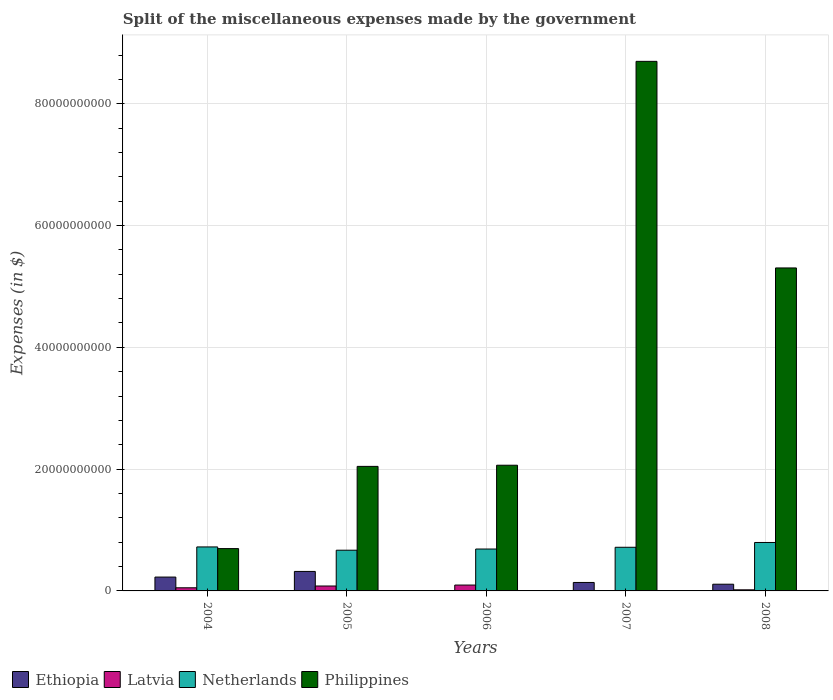How many different coloured bars are there?
Keep it short and to the point. 4. How many groups of bars are there?
Ensure brevity in your answer.  5. Are the number of bars per tick equal to the number of legend labels?
Provide a short and direct response. Yes. Are the number of bars on each tick of the X-axis equal?
Provide a succinct answer. Yes. How many bars are there on the 2nd tick from the left?
Your answer should be compact. 4. How many bars are there on the 5th tick from the right?
Give a very brief answer. 4. What is the miscellaneous expenses made by the government in Philippines in 2007?
Your answer should be compact. 8.70e+1. Across all years, what is the maximum miscellaneous expenses made by the government in Philippines?
Your response must be concise. 8.70e+1. Across all years, what is the minimum miscellaneous expenses made by the government in Ethiopia?
Provide a short and direct response. 6.20e+06. In which year was the miscellaneous expenses made by the government in Ethiopia maximum?
Provide a succinct answer. 2005. What is the total miscellaneous expenses made by the government in Netherlands in the graph?
Your response must be concise. 3.59e+1. What is the difference between the miscellaneous expenses made by the government in Ethiopia in 2006 and that in 2008?
Give a very brief answer. -1.09e+09. What is the difference between the miscellaneous expenses made by the government in Latvia in 2005 and the miscellaneous expenses made by the government in Ethiopia in 2006?
Ensure brevity in your answer.  8.00e+08. What is the average miscellaneous expenses made by the government in Netherlands per year?
Keep it short and to the point. 7.18e+09. In the year 2008, what is the difference between the miscellaneous expenses made by the government in Philippines and miscellaneous expenses made by the government in Netherlands?
Ensure brevity in your answer.  4.51e+1. What is the ratio of the miscellaneous expenses made by the government in Ethiopia in 2005 to that in 2007?
Keep it short and to the point. 2.3. Is the miscellaneous expenses made by the government in Philippines in 2004 less than that in 2006?
Provide a short and direct response. Yes. Is the difference between the miscellaneous expenses made by the government in Philippines in 2006 and 2007 greater than the difference between the miscellaneous expenses made by the government in Netherlands in 2006 and 2007?
Make the answer very short. No. What is the difference between the highest and the second highest miscellaneous expenses made by the government in Philippines?
Your response must be concise. 3.39e+1. What is the difference between the highest and the lowest miscellaneous expenses made by the government in Latvia?
Ensure brevity in your answer.  9.51e+08. What does the 2nd bar from the left in 2005 represents?
Give a very brief answer. Latvia. What does the 4th bar from the right in 2005 represents?
Provide a short and direct response. Ethiopia. Is it the case that in every year, the sum of the miscellaneous expenses made by the government in Philippines and miscellaneous expenses made by the government in Ethiopia is greater than the miscellaneous expenses made by the government in Latvia?
Provide a short and direct response. Yes. What is the difference between two consecutive major ticks on the Y-axis?
Offer a terse response. 2.00e+1. Are the values on the major ticks of Y-axis written in scientific E-notation?
Your answer should be very brief. No. Where does the legend appear in the graph?
Give a very brief answer. Bottom left. How many legend labels are there?
Make the answer very short. 4. What is the title of the graph?
Keep it short and to the point. Split of the miscellaneous expenses made by the government. What is the label or title of the X-axis?
Give a very brief answer. Years. What is the label or title of the Y-axis?
Your response must be concise. Expenses (in $). What is the Expenses (in $) in Ethiopia in 2004?
Offer a terse response. 2.27e+09. What is the Expenses (in $) of Latvia in 2004?
Provide a short and direct response. 5.13e+08. What is the Expenses (in $) of Netherlands in 2004?
Your answer should be compact. 7.22e+09. What is the Expenses (in $) of Philippines in 2004?
Offer a very short reply. 6.95e+09. What is the Expenses (in $) of Ethiopia in 2005?
Your answer should be very brief. 3.20e+09. What is the Expenses (in $) in Latvia in 2005?
Your answer should be very brief. 8.06e+08. What is the Expenses (in $) of Netherlands in 2005?
Ensure brevity in your answer.  6.69e+09. What is the Expenses (in $) in Philippines in 2005?
Your answer should be compact. 2.04e+1. What is the Expenses (in $) in Ethiopia in 2006?
Provide a succinct answer. 6.20e+06. What is the Expenses (in $) in Latvia in 2006?
Keep it short and to the point. 9.62e+08. What is the Expenses (in $) of Netherlands in 2006?
Offer a very short reply. 6.88e+09. What is the Expenses (in $) of Philippines in 2006?
Your answer should be compact. 2.06e+1. What is the Expenses (in $) in Ethiopia in 2007?
Keep it short and to the point. 1.39e+09. What is the Expenses (in $) of Latvia in 2007?
Provide a succinct answer. 1.14e+07. What is the Expenses (in $) of Netherlands in 2007?
Provide a short and direct response. 7.17e+09. What is the Expenses (in $) in Philippines in 2007?
Your response must be concise. 8.70e+1. What is the Expenses (in $) in Ethiopia in 2008?
Give a very brief answer. 1.10e+09. What is the Expenses (in $) in Latvia in 2008?
Your answer should be very brief. 1.80e+08. What is the Expenses (in $) in Netherlands in 2008?
Keep it short and to the point. 7.96e+09. What is the Expenses (in $) in Philippines in 2008?
Provide a short and direct response. 5.30e+1. Across all years, what is the maximum Expenses (in $) in Ethiopia?
Your answer should be very brief. 3.20e+09. Across all years, what is the maximum Expenses (in $) in Latvia?
Ensure brevity in your answer.  9.62e+08. Across all years, what is the maximum Expenses (in $) in Netherlands?
Keep it short and to the point. 7.96e+09. Across all years, what is the maximum Expenses (in $) in Philippines?
Provide a short and direct response. 8.70e+1. Across all years, what is the minimum Expenses (in $) of Ethiopia?
Your answer should be compact. 6.20e+06. Across all years, what is the minimum Expenses (in $) in Latvia?
Ensure brevity in your answer.  1.14e+07. Across all years, what is the minimum Expenses (in $) in Netherlands?
Offer a very short reply. 6.69e+09. Across all years, what is the minimum Expenses (in $) of Philippines?
Ensure brevity in your answer.  6.95e+09. What is the total Expenses (in $) of Ethiopia in the graph?
Your response must be concise. 7.97e+09. What is the total Expenses (in $) of Latvia in the graph?
Offer a terse response. 2.47e+09. What is the total Expenses (in $) in Netherlands in the graph?
Provide a short and direct response. 3.59e+1. What is the total Expenses (in $) in Philippines in the graph?
Ensure brevity in your answer.  1.88e+11. What is the difference between the Expenses (in $) in Ethiopia in 2004 and that in 2005?
Keep it short and to the point. -9.25e+08. What is the difference between the Expenses (in $) in Latvia in 2004 and that in 2005?
Provide a short and direct response. -2.92e+08. What is the difference between the Expenses (in $) in Netherlands in 2004 and that in 2005?
Offer a terse response. 5.37e+08. What is the difference between the Expenses (in $) in Philippines in 2004 and that in 2005?
Keep it short and to the point. -1.35e+1. What is the difference between the Expenses (in $) of Ethiopia in 2004 and that in 2006?
Your response must be concise. 2.27e+09. What is the difference between the Expenses (in $) in Latvia in 2004 and that in 2006?
Keep it short and to the point. -4.49e+08. What is the difference between the Expenses (in $) of Netherlands in 2004 and that in 2006?
Make the answer very short. 3.43e+08. What is the difference between the Expenses (in $) in Philippines in 2004 and that in 2006?
Your response must be concise. -1.37e+1. What is the difference between the Expenses (in $) of Ethiopia in 2004 and that in 2007?
Give a very brief answer. 8.85e+08. What is the difference between the Expenses (in $) in Latvia in 2004 and that in 2007?
Provide a succinct answer. 5.02e+08. What is the difference between the Expenses (in $) of Netherlands in 2004 and that in 2007?
Your response must be concise. 5.60e+07. What is the difference between the Expenses (in $) in Philippines in 2004 and that in 2007?
Your response must be concise. -8.00e+1. What is the difference between the Expenses (in $) of Ethiopia in 2004 and that in 2008?
Provide a succinct answer. 1.17e+09. What is the difference between the Expenses (in $) of Latvia in 2004 and that in 2008?
Make the answer very short. 3.33e+08. What is the difference between the Expenses (in $) in Netherlands in 2004 and that in 2008?
Give a very brief answer. -7.33e+08. What is the difference between the Expenses (in $) of Philippines in 2004 and that in 2008?
Keep it short and to the point. -4.61e+1. What is the difference between the Expenses (in $) of Ethiopia in 2005 and that in 2006?
Ensure brevity in your answer.  3.19e+09. What is the difference between the Expenses (in $) of Latvia in 2005 and that in 2006?
Ensure brevity in your answer.  -1.56e+08. What is the difference between the Expenses (in $) of Netherlands in 2005 and that in 2006?
Give a very brief answer. -1.94e+08. What is the difference between the Expenses (in $) in Philippines in 2005 and that in 2006?
Make the answer very short. -1.90e+08. What is the difference between the Expenses (in $) in Ethiopia in 2005 and that in 2007?
Your answer should be compact. 1.81e+09. What is the difference between the Expenses (in $) of Latvia in 2005 and that in 2007?
Make the answer very short. 7.94e+08. What is the difference between the Expenses (in $) of Netherlands in 2005 and that in 2007?
Your response must be concise. -4.81e+08. What is the difference between the Expenses (in $) of Philippines in 2005 and that in 2007?
Your answer should be compact. -6.65e+1. What is the difference between the Expenses (in $) of Ethiopia in 2005 and that in 2008?
Provide a succinct answer. 2.10e+09. What is the difference between the Expenses (in $) in Latvia in 2005 and that in 2008?
Your answer should be compact. 6.26e+08. What is the difference between the Expenses (in $) of Netherlands in 2005 and that in 2008?
Make the answer very short. -1.27e+09. What is the difference between the Expenses (in $) in Philippines in 2005 and that in 2008?
Your answer should be very brief. -3.26e+1. What is the difference between the Expenses (in $) of Ethiopia in 2006 and that in 2007?
Provide a short and direct response. -1.38e+09. What is the difference between the Expenses (in $) of Latvia in 2006 and that in 2007?
Provide a succinct answer. 9.51e+08. What is the difference between the Expenses (in $) in Netherlands in 2006 and that in 2007?
Your response must be concise. -2.87e+08. What is the difference between the Expenses (in $) of Philippines in 2006 and that in 2007?
Your answer should be compact. -6.63e+1. What is the difference between the Expenses (in $) in Ethiopia in 2006 and that in 2008?
Provide a short and direct response. -1.09e+09. What is the difference between the Expenses (in $) in Latvia in 2006 and that in 2008?
Offer a very short reply. 7.82e+08. What is the difference between the Expenses (in $) in Netherlands in 2006 and that in 2008?
Your answer should be very brief. -1.08e+09. What is the difference between the Expenses (in $) in Philippines in 2006 and that in 2008?
Offer a terse response. -3.24e+1. What is the difference between the Expenses (in $) in Ethiopia in 2007 and that in 2008?
Provide a short and direct response. 2.89e+08. What is the difference between the Expenses (in $) of Latvia in 2007 and that in 2008?
Provide a short and direct response. -1.69e+08. What is the difference between the Expenses (in $) of Netherlands in 2007 and that in 2008?
Your answer should be very brief. -7.89e+08. What is the difference between the Expenses (in $) in Philippines in 2007 and that in 2008?
Ensure brevity in your answer.  3.39e+1. What is the difference between the Expenses (in $) in Ethiopia in 2004 and the Expenses (in $) in Latvia in 2005?
Give a very brief answer. 1.47e+09. What is the difference between the Expenses (in $) in Ethiopia in 2004 and the Expenses (in $) in Netherlands in 2005?
Give a very brief answer. -4.41e+09. What is the difference between the Expenses (in $) in Ethiopia in 2004 and the Expenses (in $) in Philippines in 2005?
Provide a succinct answer. -1.82e+1. What is the difference between the Expenses (in $) of Latvia in 2004 and the Expenses (in $) of Netherlands in 2005?
Your answer should be compact. -6.17e+09. What is the difference between the Expenses (in $) in Latvia in 2004 and the Expenses (in $) in Philippines in 2005?
Your answer should be compact. -1.99e+1. What is the difference between the Expenses (in $) in Netherlands in 2004 and the Expenses (in $) in Philippines in 2005?
Give a very brief answer. -1.32e+1. What is the difference between the Expenses (in $) in Ethiopia in 2004 and the Expenses (in $) in Latvia in 2006?
Offer a terse response. 1.31e+09. What is the difference between the Expenses (in $) of Ethiopia in 2004 and the Expenses (in $) of Netherlands in 2006?
Offer a terse response. -4.61e+09. What is the difference between the Expenses (in $) of Ethiopia in 2004 and the Expenses (in $) of Philippines in 2006?
Ensure brevity in your answer.  -1.84e+1. What is the difference between the Expenses (in $) of Latvia in 2004 and the Expenses (in $) of Netherlands in 2006?
Your answer should be very brief. -6.37e+09. What is the difference between the Expenses (in $) in Latvia in 2004 and the Expenses (in $) in Philippines in 2006?
Provide a short and direct response. -2.01e+1. What is the difference between the Expenses (in $) of Netherlands in 2004 and the Expenses (in $) of Philippines in 2006?
Give a very brief answer. -1.34e+1. What is the difference between the Expenses (in $) of Ethiopia in 2004 and the Expenses (in $) of Latvia in 2007?
Provide a succinct answer. 2.26e+09. What is the difference between the Expenses (in $) of Ethiopia in 2004 and the Expenses (in $) of Netherlands in 2007?
Keep it short and to the point. -4.89e+09. What is the difference between the Expenses (in $) in Ethiopia in 2004 and the Expenses (in $) in Philippines in 2007?
Offer a terse response. -8.47e+1. What is the difference between the Expenses (in $) in Latvia in 2004 and the Expenses (in $) in Netherlands in 2007?
Give a very brief answer. -6.65e+09. What is the difference between the Expenses (in $) in Latvia in 2004 and the Expenses (in $) in Philippines in 2007?
Keep it short and to the point. -8.64e+1. What is the difference between the Expenses (in $) of Netherlands in 2004 and the Expenses (in $) of Philippines in 2007?
Provide a short and direct response. -7.97e+1. What is the difference between the Expenses (in $) in Ethiopia in 2004 and the Expenses (in $) in Latvia in 2008?
Your response must be concise. 2.09e+09. What is the difference between the Expenses (in $) in Ethiopia in 2004 and the Expenses (in $) in Netherlands in 2008?
Your answer should be very brief. -5.68e+09. What is the difference between the Expenses (in $) in Ethiopia in 2004 and the Expenses (in $) in Philippines in 2008?
Ensure brevity in your answer.  -5.08e+1. What is the difference between the Expenses (in $) of Latvia in 2004 and the Expenses (in $) of Netherlands in 2008?
Provide a short and direct response. -7.44e+09. What is the difference between the Expenses (in $) of Latvia in 2004 and the Expenses (in $) of Philippines in 2008?
Provide a short and direct response. -5.25e+1. What is the difference between the Expenses (in $) in Netherlands in 2004 and the Expenses (in $) in Philippines in 2008?
Your response must be concise. -4.58e+1. What is the difference between the Expenses (in $) of Ethiopia in 2005 and the Expenses (in $) of Latvia in 2006?
Provide a succinct answer. 2.24e+09. What is the difference between the Expenses (in $) in Ethiopia in 2005 and the Expenses (in $) in Netherlands in 2006?
Offer a very short reply. -3.68e+09. What is the difference between the Expenses (in $) in Ethiopia in 2005 and the Expenses (in $) in Philippines in 2006?
Your answer should be very brief. -1.74e+1. What is the difference between the Expenses (in $) of Latvia in 2005 and the Expenses (in $) of Netherlands in 2006?
Provide a succinct answer. -6.07e+09. What is the difference between the Expenses (in $) of Latvia in 2005 and the Expenses (in $) of Philippines in 2006?
Ensure brevity in your answer.  -1.98e+1. What is the difference between the Expenses (in $) of Netherlands in 2005 and the Expenses (in $) of Philippines in 2006?
Your answer should be compact. -1.40e+1. What is the difference between the Expenses (in $) of Ethiopia in 2005 and the Expenses (in $) of Latvia in 2007?
Your answer should be compact. 3.19e+09. What is the difference between the Expenses (in $) in Ethiopia in 2005 and the Expenses (in $) in Netherlands in 2007?
Offer a terse response. -3.97e+09. What is the difference between the Expenses (in $) of Ethiopia in 2005 and the Expenses (in $) of Philippines in 2007?
Offer a terse response. -8.38e+1. What is the difference between the Expenses (in $) of Latvia in 2005 and the Expenses (in $) of Netherlands in 2007?
Provide a succinct answer. -6.36e+09. What is the difference between the Expenses (in $) of Latvia in 2005 and the Expenses (in $) of Philippines in 2007?
Your answer should be very brief. -8.62e+1. What is the difference between the Expenses (in $) of Netherlands in 2005 and the Expenses (in $) of Philippines in 2007?
Ensure brevity in your answer.  -8.03e+1. What is the difference between the Expenses (in $) in Ethiopia in 2005 and the Expenses (in $) in Latvia in 2008?
Provide a succinct answer. 3.02e+09. What is the difference between the Expenses (in $) in Ethiopia in 2005 and the Expenses (in $) in Netherlands in 2008?
Your response must be concise. -4.76e+09. What is the difference between the Expenses (in $) in Ethiopia in 2005 and the Expenses (in $) in Philippines in 2008?
Offer a very short reply. -4.98e+1. What is the difference between the Expenses (in $) of Latvia in 2005 and the Expenses (in $) of Netherlands in 2008?
Make the answer very short. -7.15e+09. What is the difference between the Expenses (in $) in Latvia in 2005 and the Expenses (in $) in Philippines in 2008?
Provide a succinct answer. -5.22e+1. What is the difference between the Expenses (in $) of Netherlands in 2005 and the Expenses (in $) of Philippines in 2008?
Your answer should be compact. -4.63e+1. What is the difference between the Expenses (in $) of Ethiopia in 2006 and the Expenses (in $) of Latvia in 2007?
Make the answer very short. -5.20e+06. What is the difference between the Expenses (in $) of Ethiopia in 2006 and the Expenses (in $) of Netherlands in 2007?
Your response must be concise. -7.16e+09. What is the difference between the Expenses (in $) in Ethiopia in 2006 and the Expenses (in $) in Philippines in 2007?
Your answer should be very brief. -8.70e+1. What is the difference between the Expenses (in $) in Latvia in 2006 and the Expenses (in $) in Netherlands in 2007?
Provide a short and direct response. -6.20e+09. What is the difference between the Expenses (in $) in Latvia in 2006 and the Expenses (in $) in Philippines in 2007?
Offer a very short reply. -8.60e+1. What is the difference between the Expenses (in $) of Netherlands in 2006 and the Expenses (in $) of Philippines in 2007?
Your answer should be compact. -8.01e+1. What is the difference between the Expenses (in $) of Ethiopia in 2006 and the Expenses (in $) of Latvia in 2008?
Your response must be concise. -1.74e+08. What is the difference between the Expenses (in $) of Ethiopia in 2006 and the Expenses (in $) of Netherlands in 2008?
Your answer should be very brief. -7.95e+09. What is the difference between the Expenses (in $) in Ethiopia in 2006 and the Expenses (in $) in Philippines in 2008?
Your response must be concise. -5.30e+1. What is the difference between the Expenses (in $) of Latvia in 2006 and the Expenses (in $) of Netherlands in 2008?
Your response must be concise. -6.99e+09. What is the difference between the Expenses (in $) in Latvia in 2006 and the Expenses (in $) in Philippines in 2008?
Your answer should be very brief. -5.21e+1. What is the difference between the Expenses (in $) of Netherlands in 2006 and the Expenses (in $) of Philippines in 2008?
Provide a short and direct response. -4.62e+1. What is the difference between the Expenses (in $) of Ethiopia in 2007 and the Expenses (in $) of Latvia in 2008?
Provide a short and direct response. 1.21e+09. What is the difference between the Expenses (in $) of Ethiopia in 2007 and the Expenses (in $) of Netherlands in 2008?
Your answer should be compact. -6.57e+09. What is the difference between the Expenses (in $) of Ethiopia in 2007 and the Expenses (in $) of Philippines in 2008?
Keep it short and to the point. -5.16e+1. What is the difference between the Expenses (in $) of Latvia in 2007 and the Expenses (in $) of Netherlands in 2008?
Provide a short and direct response. -7.94e+09. What is the difference between the Expenses (in $) of Latvia in 2007 and the Expenses (in $) of Philippines in 2008?
Provide a succinct answer. -5.30e+1. What is the difference between the Expenses (in $) of Netherlands in 2007 and the Expenses (in $) of Philippines in 2008?
Your answer should be compact. -4.59e+1. What is the average Expenses (in $) of Ethiopia per year?
Give a very brief answer. 1.59e+09. What is the average Expenses (in $) of Latvia per year?
Give a very brief answer. 4.94e+08. What is the average Expenses (in $) of Netherlands per year?
Your answer should be compact. 7.18e+09. What is the average Expenses (in $) in Philippines per year?
Ensure brevity in your answer.  3.76e+1. In the year 2004, what is the difference between the Expenses (in $) in Ethiopia and Expenses (in $) in Latvia?
Ensure brevity in your answer.  1.76e+09. In the year 2004, what is the difference between the Expenses (in $) of Ethiopia and Expenses (in $) of Netherlands?
Keep it short and to the point. -4.95e+09. In the year 2004, what is the difference between the Expenses (in $) in Ethiopia and Expenses (in $) in Philippines?
Give a very brief answer. -4.68e+09. In the year 2004, what is the difference between the Expenses (in $) in Latvia and Expenses (in $) in Netherlands?
Your answer should be compact. -6.71e+09. In the year 2004, what is the difference between the Expenses (in $) in Latvia and Expenses (in $) in Philippines?
Ensure brevity in your answer.  -6.44e+09. In the year 2004, what is the difference between the Expenses (in $) in Netherlands and Expenses (in $) in Philippines?
Make the answer very short. 2.73e+08. In the year 2005, what is the difference between the Expenses (in $) of Ethiopia and Expenses (in $) of Latvia?
Make the answer very short. 2.39e+09. In the year 2005, what is the difference between the Expenses (in $) in Ethiopia and Expenses (in $) in Netherlands?
Offer a very short reply. -3.49e+09. In the year 2005, what is the difference between the Expenses (in $) in Ethiopia and Expenses (in $) in Philippines?
Provide a short and direct response. -1.73e+1. In the year 2005, what is the difference between the Expenses (in $) of Latvia and Expenses (in $) of Netherlands?
Make the answer very short. -5.88e+09. In the year 2005, what is the difference between the Expenses (in $) in Latvia and Expenses (in $) in Philippines?
Provide a short and direct response. -1.96e+1. In the year 2005, what is the difference between the Expenses (in $) in Netherlands and Expenses (in $) in Philippines?
Your answer should be very brief. -1.38e+1. In the year 2006, what is the difference between the Expenses (in $) of Ethiopia and Expenses (in $) of Latvia?
Give a very brief answer. -9.56e+08. In the year 2006, what is the difference between the Expenses (in $) in Ethiopia and Expenses (in $) in Netherlands?
Offer a very short reply. -6.87e+09. In the year 2006, what is the difference between the Expenses (in $) of Ethiopia and Expenses (in $) of Philippines?
Ensure brevity in your answer.  -2.06e+1. In the year 2006, what is the difference between the Expenses (in $) in Latvia and Expenses (in $) in Netherlands?
Ensure brevity in your answer.  -5.92e+09. In the year 2006, what is the difference between the Expenses (in $) of Latvia and Expenses (in $) of Philippines?
Your answer should be very brief. -1.97e+1. In the year 2006, what is the difference between the Expenses (in $) of Netherlands and Expenses (in $) of Philippines?
Provide a short and direct response. -1.38e+1. In the year 2007, what is the difference between the Expenses (in $) in Ethiopia and Expenses (in $) in Latvia?
Offer a terse response. 1.38e+09. In the year 2007, what is the difference between the Expenses (in $) in Ethiopia and Expenses (in $) in Netherlands?
Keep it short and to the point. -5.78e+09. In the year 2007, what is the difference between the Expenses (in $) in Ethiopia and Expenses (in $) in Philippines?
Your answer should be compact. -8.56e+1. In the year 2007, what is the difference between the Expenses (in $) in Latvia and Expenses (in $) in Netherlands?
Your answer should be compact. -7.16e+09. In the year 2007, what is the difference between the Expenses (in $) in Latvia and Expenses (in $) in Philippines?
Keep it short and to the point. -8.69e+1. In the year 2007, what is the difference between the Expenses (in $) in Netherlands and Expenses (in $) in Philippines?
Offer a very short reply. -7.98e+1. In the year 2008, what is the difference between the Expenses (in $) of Ethiopia and Expenses (in $) of Latvia?
Offer a terse response. 9.21e+08. In the year 2008, what is the difference between the Expenses (in $) of Ethiopia and Expenses (in $) of Netherlands?
Give a very brief answer. -6.86e+09. In the year 2008, what is the difference between the Expenses (in $) of Ethiopia and Expenses (in $) of Philippines?
Your answer should be compact. -5.19e+1. In the year 2008, what is the difference between the Expenses (in $) of Latvia and Expenses (in $) of Netherlands?
Your response must be concise. -7.78e+09. In the year 2008, what is the difference between the Expenses (in $) of Latvia and Expenses (in $) of Philippines?
Give a very brief answer. -5.29e+1. In the year 2008, what is the difference between the Expenses (in $) in Netherlands and Expenses (in $) in Philippines?
Provide a succinct answer. -4.51e+1. What is the ratio of the Expenses (in $) in Ethiopia in 2004 to that in 2005?
Offer a terse response. 0.71. What is the ratio of the Expenses (in $) of Latvia in 2004 to that in 2005?
Give a very brief answer. 0.64. What is the ratio of the Expenses (in $) in Netherlands in 2004 to that in 2005?
Provide a short and direct response. 1.08. What is the ratio of the Expenses (in $) of Philippines in 2004 to that in 2005?
Offer a very short reply. 0.34. What is the ratio of the Expenses (in $) in Ethiopia in 2004 to that in 2006?
Your answer should be very brief. 366.84. What is the ratio of the Expenses (in $) in Latvia in 2004 to that in 2006?
Provide a short and direct response. 0.53. What is the ratio of the Expenses (in $) of Netherlands in 2004 to that in 2006?
Your answer should be compact. 1.05. What is the ratio of the Expenses (in $) of Philippines in 2004 to that in 2006?
Make the answer very short. 0.34. What is the ratio of the Expenses (in $) of Ethiopia in 2004 to that in 2007?
Make the answer very short. 1.64. What is the ratio of the Expenses (in $) of Latvia in 2004 to that in 2007?
Your answer should be compact. 45.02. What is the ratio of the Expenses (in $) in Netherlands in 2004 to that in 2007?
Ensure brevity in your answer.  1.01. What is the ratio of the Expenses (in $) in Philippines in 2004 to that in 2007?
Your answer should be compact. 0.08. What is the ratio of the Expenses (in $) of Ethiopia in 2004 to that in 2008?
Give a very brief answer. 2.07. What is the ratio of the Expenses (in $) in Latvia in 2004 to that in 2008?
Ensure brevity in your answer.  2.85. What is the ratio of the Expenses (in $) of Netherlands in 2004 to that in 2008?
Provide a succinct answer. 0.91. What is the ratio of the Expenses (in $) in Philippines in 2004 to that in 2008?
Provide a succinct answer. 0.13. What is the ratio of the Expenses (in $) in Ethiopia in 2005 to that in 2006?
Your response must be concise. 516.06. What is the ratio of the Expenses (in $) of Latvia in 2005 to that in 2006?
Give a very brief answer. 0.84. What is the ratio of the Expenses (in $) of Netherlands in 2005 to that in 2006?
Make the answer very short. 0.97. What is the ratio of the Expenses (in $) in Ethiopia in 2005 to that in 2007?
Your answer should be very brief. 2.3. What is the ratio of the Expenses (in $) of Latvia in 2005 to that in 2007?
Your response must be concise. 70.68. What is the ratio of the Expenses (in $) in Netherlands in 2005 to that in 2007?
Offer a terse response. 0.93. What is the ratio of the Expenses (in $) in Philippines in 2005 to that in 2007?
Offer a very short reply. 0.24. What is the ratio of the Expenses (in $) in Ethiopia in 2005 to that in 2008?
Offer a very short reply. 2.91. What is the ratio of the Expenses (in $) of Latvia in 2005 to that in 2008?
Provide a succinct answer. 4.48. What is the ratio of the Expenses (in $) in Netherlands in 2005 to that in 2008?
Provide a short and direct response. 0.84. What is the ratio of the Expenses (in $) in Philippines in 2005 to that in 2008?
Keep it short and to the point. 0.39. What is the ratio of the Expenses (in $) in Ethiopia in 2006 to that in 2007?
Keep it short and to the point. 0. What is the ratio of the Expenses (in $) of Latvia in 2006 to that in 2007?
Your response must be concise. 84.39. What is the ratio of the Expenses (in $) of Philippines in 2006 to that in 2007?
Provide a short and direct response. 0.24. What is the ratio of the Expenses (in $) of Ethiopia in 2006 to that in 2008?
Make the answer very short. 0.01. What is the ratio of the Expenses (in $) in Latvia in 2006 to that in 2008?
Keep it short and to the point. 5.34. What is the ratio of the Expenses (in $) of Netherlands in 2006 to that in 2008?
Provide a succinct answer. 0.86. What is the ratio of the Expenses (in $) of Philippines in 2006 to that in 2008?
Your response must be concise. 0.39. What is the ratio of the Expenses (in $) of Ethiopia in 2007 to that in 2008?
Offer a terse response. 1.26. What is the ratio of the Expenses (in $) in Latvia in 2007 to that in 2008?
Your answer should be very brief. 0.06. What is the ratio of the Expenses (in $) in Netherlands in 2007 to that in 2008?
Offer a very short reply. 0.9. What is the ratio of the Expenses (in $) of Philippines in 2007 to that in 2008?
Keep it short and to the point. 1.64. What is the difference between the highest and the second highest Expenses (in $) of Ethiopia?
Offer a very short reply. 9.25e+08. What is the difference between the highest and the second highest Expenses (in $) of Latvia?
Offer a very short reply. 1.56e+08. What is the difference between the highest and the second highest Expenses (in $) in Netherlands?
Make the answer very short. 7.33e+08. What is the difference between the highest and the second highest Expenses (in $) in Philippines?
Your answer should be compact. 3.39e+1. What is the difference between the highest and the lowest Expenses (in $) of Ethiopia?
Provide a succinct answer. 3.19e+09. What is the difference between the highest and the lowest Expenses (in $) in Latvia?
Your answer should be compact. 9.51e+08. What is the difference between the highest and the lowest Expenses (in $) in Netherlands?
Give a very brief answer. 1.27e+09. What is the difference between the highest and the lowest Expenses (in $) in Philippines?
Make the answer very short. 8.00e+1. 